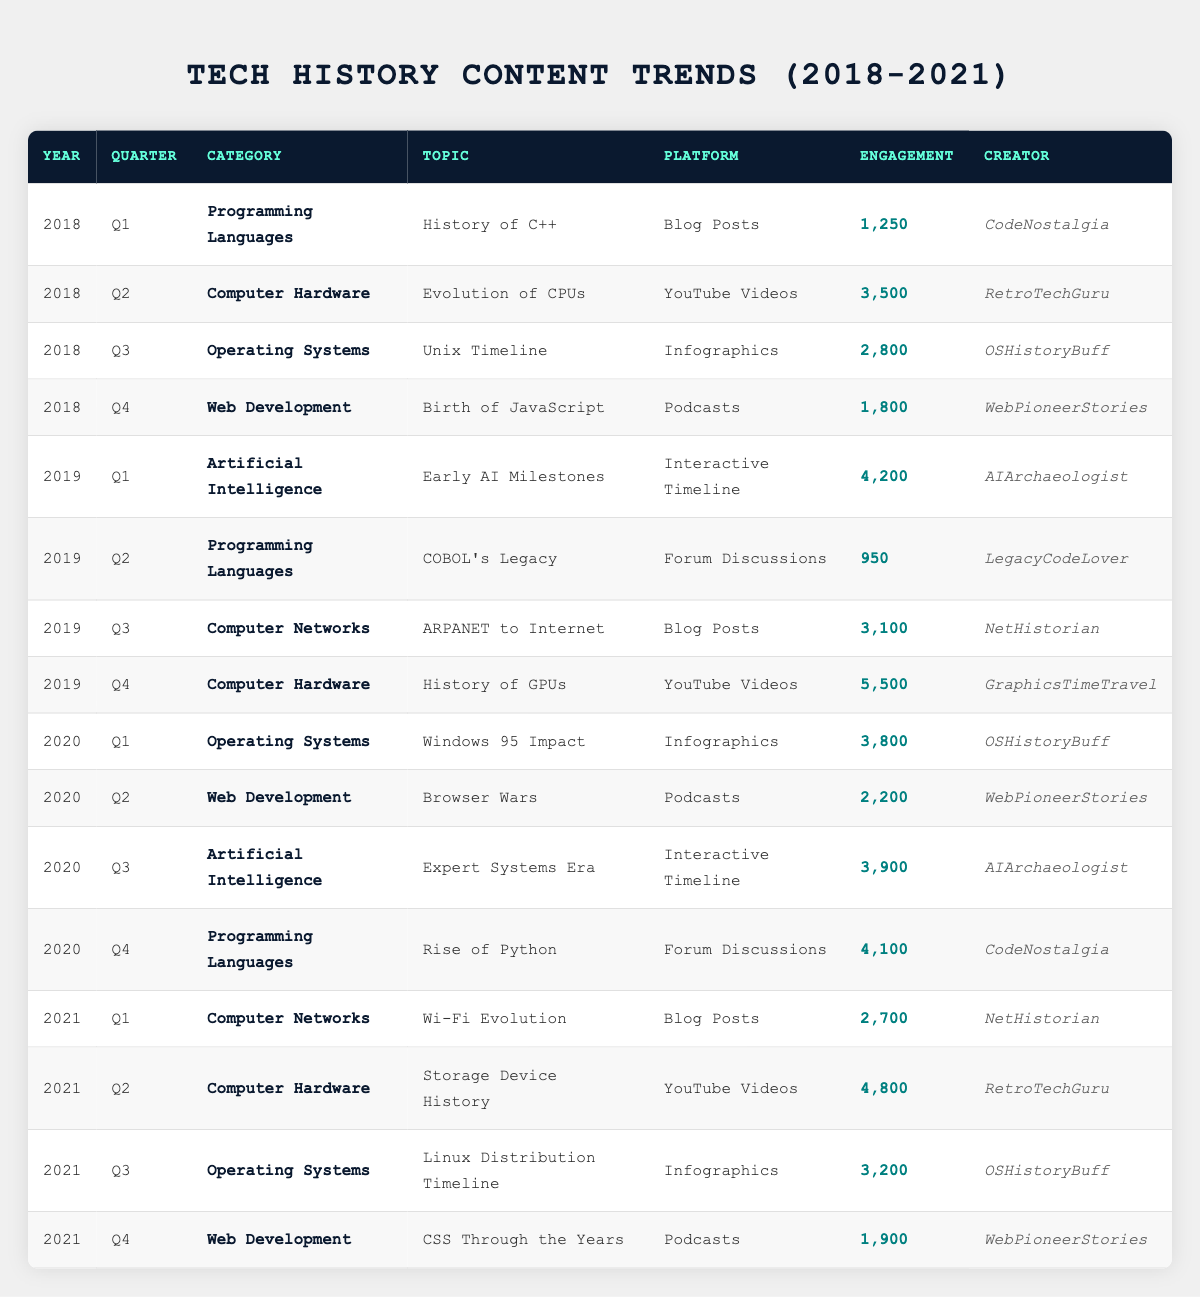What is the highest engagement recorded in the data? The maximum engagement can be found by reviewing the engagement column in the table. Scanning through the values, the highest engagement is 5,500, which corresponds to the topic "History of GPUs" in Q4 of 2019.
Answer: 5,500 Which creator produced content in the Web Development category? By examining the rows in the table for the Web Development category, we can identify that "WebPioneerStories" created content for Q4 of 2018, Q2 of 2020, and Q4 of 2021.
Answer: WebPioneerStories What is the average engagement across all programming languages topics? The programming languages topics are "History of C++", "COBOL's Legacy", and "Rise of Python", with engagements of 1,250, 950, and 4,100, respectively. The sum is 1,250 + 950 + 4,100 = 6,300. Dividing by the number of topics (3) gives an average of 6,300 / 3 = 2,100.
Answer: 2,100 In which quarter did the "Expert Systems Era" topic receive engagement? Looking through the table, the engagement for "Expert Systems Era" is found in Q3 of 2020.
Answer: Q3 2020 Is there any topic related to Artificial Intelligence in 2018? Checking the table for any row with the category "Artificial Intelligence" and the year 2018, none are found because the first entry under this category appears in Q1 of 2019.
Answer: No What is the total engagement for Computer Hardware topics across all years? The Computer Hardware topics and their engagements are "Evolution of CPUs" (3,500), "History of GPUs" (5,500), and "Storage Device History" (4,800). Summing these gives a total engagement of 3,500 + 5,500 + 4,800 = 13,800.
Answer: 13,800 Which technology category has the highest total engagement from Q1 to Q4 in 2019? Calculating the total engagement for 2019, we see that "Artificial Intelligence" has 4,200 (Q1), "Programming Languages" has 950 (Q2), "Computer Networks" has 3,100 (Q3), and "Computer Hardware" has 5,500 (Q4). The total is 4,200 + 950 + 3,100 + 5,500 = 13,750, thus identifying that Computer Hardware has the highest total engagement for that year.
Answer: Computer Hardware What platform had the most engagement in Q2 of 2021? In Q2 of 2021, the selected platform is “YouTube Videos” with "Storage Device History", which recorded 4,800 engagements, making it the platform with the highest engagement for that quarter.
Answer: YouTube Videos 